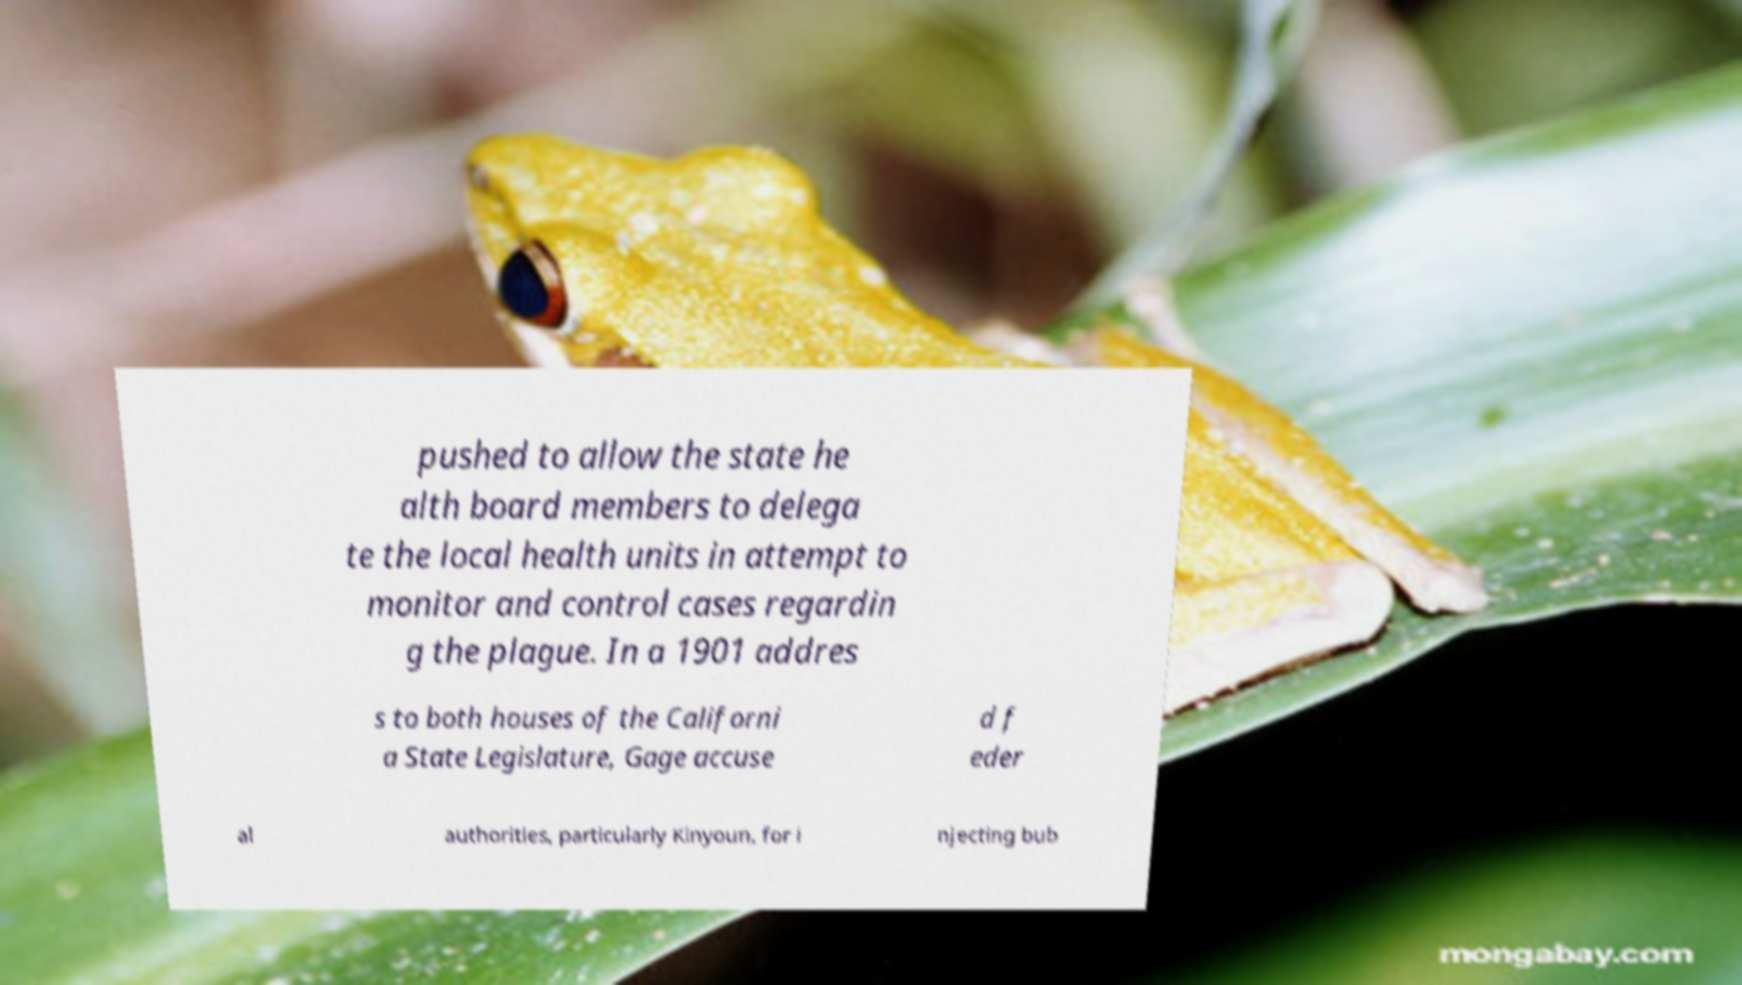Could you assist in decoding the text presented in this image and type it out clearly? pushed to allow the state he alth board members to delega te the local health units in attempt to monitor and control cases regardin g the plague. In a 1901 addres s to both houses of the Californi a State Legislature, Gage accuse d f eder al authorities, particularly Kinyoun, for i njecting bub 